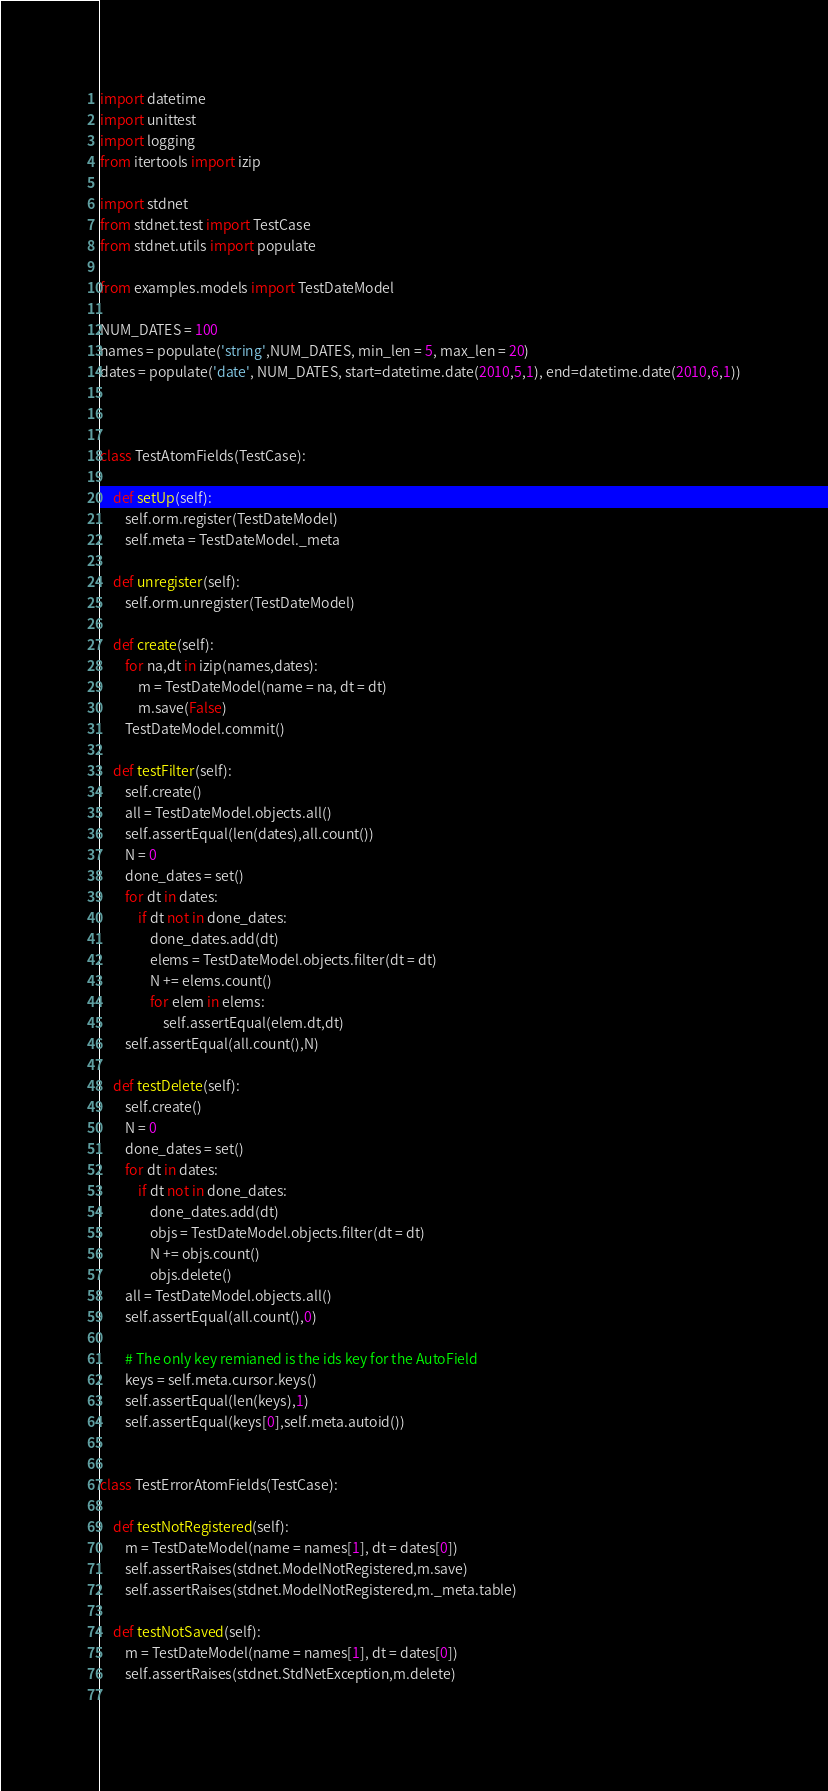Convert code to text. <code><loc_0><loc_0><loc_500><loc_500><_Python_>import datetime
import unittest
import logging
from itertools import izip

import stdnet
from stdnet.test import TestCase
from stdnet.utils import populate

from examples.models import TestDateModel

NUM_DATES = 100
names = populate('string',NUM_DATES, min_len = 5, max_len = 20)
dates = populate('date', NUM_DATES, start=datetime.date(2010,5,1), end=datetime.date(2010,6,1))



class TestAtomFields(TestCase):
    
    def setUp(self):
        self.orm.register(TestDateModel)
        self.meta = TestDateModel._meta
    
    def unregister(self):
        self.orm.unregister(TestDateModel)
        
    def create(self):
        for na,dt in izip(names,dates):
            m = TestDateModel(name = na, dt = dt)
            m.save(False)
        TestDateModel.commit()
            
    def testFilter(self):
        self.create()
        all = TestDateModel.objects.all()
        self.assertEqual(len(dates),all.count())
        N = 0
        done_dates = set()
        for dt in dates:
            if dt not in done_dates:
                done_dates.add(dt)
                elems = TestDateModel.objects.filter(dt = dt)
                N += elems.count()
                for elem in elems:
                    self.assertEqual(elem.dt,dt)
        self.assertEqual(all.count(),N)
        
    def testDelete(self):
        self.create()
        N = 0
        done_dates = set()
        for dt in dates:
            if dt not in done_dates:
                done_dates.add(dt)
                objs = TestDateModel.objects.filter(dt = dt)
                N += objs.count()
                objs.delete()
        all = TestDateModel.objects.all()
        self.assertEqual(all.count(),0)
        
        # The only key remianed is the ids key for the AutoField
        keys = self.meta.cursor.keys()
        self.assertEqual(len(keys),1)
        self.assertEqual(keys[0],self.meta.autoid())
        

class TestErrorAtomFields(TestCase):
    
    def testNotRegistered(self):
        m = TestDateModel(name = names[1], dt = dates[0])
        self.assertRaises(stdnet.ModelNotRegistered,m.save)
        self.assertRaises(stdnet.ModelNotRegistered,m._meta.table)
    
    def testNotSaved(self):
        m = TestDateModel(name = names[1], dt = dates[0])
        self.assertRaises(stdnet.StdNetException,m.delete)    
            </code> 